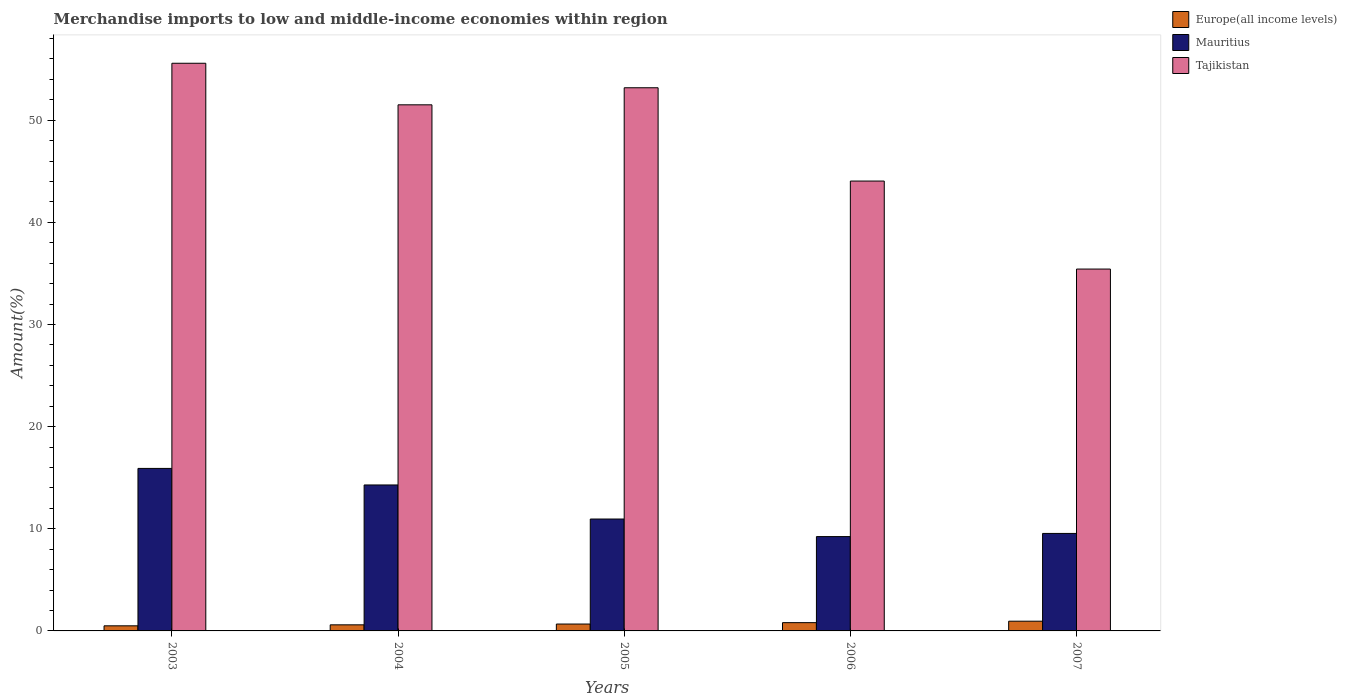How many groups of bars are there?
Offer a terse response. 5. How many bars are there on the 1st tick from the right?
Give a very brief answer. 3. What is the label of the 4th group of bars from the left?
Give a very brief answer. 2006. In how many cases, is the number of bars for a given year not equal to the number of legend labels?
Provide a succinct answer. 0. What is the percentage of amount earned from merchandise imports in Mauritius in 2005?
Offer a very short reply. 10.95. Across all years, what is the maximum percentage of amount earned from merchandise imports in Europe(all income levels)?
Make the answer very short. 0.95. Across all years, what is the minimum percentage of amount earned from merchandise imports in Mauritius?
Provide a short and direct response. 9.23. In which year was the percentage of amount earned from merchandise imports in Europe(all income levels) maximum?
Offer a very short reply. 2007. In which year was the percentage of amount earned from merchandise imports in Tajikistan minimum?
Ensure brevity in your answer.  2007. What is the total percentage of amount earned from merchandise imports in Mauritius in the graph?
Your answer should be compact. 59.93. What is the difference between the percentage of amount earned from merchandise imports in Tajikistan in 2003 and that in 2005?
Offer a terse response. 2.4. What is the difference between the percentage of amount earned from merchandise imports in Europe(all income levels) in 2007 and the percentage of amount earned from merchandise imports in Mauritius in 2004?
Your response must be concise. -13.34. What is the average percentage of amount earned from merchandise imports in Tajikistan per year?
Provide a short and direct response. 47.94. In the year 2004, what is the difference between the percentage of amount earned from merchandise imports in Europe(all income levels) and percentage of amount earned from merchandise imports in Tajikistan?
Offer a terse response. -50.91. What is the ratio of the percentage of amount earned from merchandise imports in Europe(all income levels) in 2006 to that in 2007?
Offer a terse response. 0.85. Is the percentage of amount earned from merchandise imports in Mauritius in 2005 less than that in 2007?
Ensure brevity in your answer.  No. What is the difference between the highest and the second highest percentage of amount earned from merchandise imports in Europe(all income levels)?
Your answer should be compact. 0.14. What is the difference between the highest and the lowest percentage of amount earned from merchandise imports in Tajikistan?
Your response must be concise. 20.15. In how many years, is the percentage of amount earned from merchandise imports in Europe(all income levels) greater than the average percentage of amount earned from merchandise imports in Europe(all income levels) taken over all years?
Make the answer very short. 2. What does the 3rd bar from the left in 2006 represents?
Provide a succinct answer. Tajikistan. What does the 1st bar from the right in 2003 represents?
Your answer should be compact. Tajikistan. Is it the case that in every year, the sum of the percentage of amount earned from merchandise imports in Mauritius and percentage of amount earned from merchandise imports in Europe(all income levels) is greater than the percentage of amount earned from merchandise imports in Tajikistan?
Your answer should be compact. No. How many bars are there?
Give a very brief answer. 15. Are the values on the major ticks of Y-axis written in scientific E-notation?
Make the answer very short. No. Does the graph contain grids?
Offer a terse response. No. How are the legend labels stacked?
Your answer should be very brief. Vertical. What is the title of the graph?
Give a very brief answer. Merchandise imports to low and middle-income economies within region. Does "El Salvador" appear as one of the legend labels in the graph?
Provide a short and direct response. No. What is the label or title of the Y-axis?
Ensure brevity in your answer.  Amount(%). What is the Amount(%) of Europe(all income levels) in 2003?
Keep it short and to the point. 0.5. What is the Amount(%) in Mauritius in 2003?
Offer a very short reply. 15.91. What is the Amount(%) in Tajikistan in 2003?
Offer a very short reply. 55.57. What is the Amount(%) in Europe(all income levels) in 2004?
Keep it short and to the point. 0.6. What is the Amount(%) in Mauritius in 2004?
Your answer should be very brief. 14.29. What is the Amount(%) of Tajikistan in 2004?
Make the answer very short. 51.5. What is the Amount(%) in Europe(all income levels) in 2005?
Your answer should be compact. 0.67. What is the Amount(%) in Mauritius in 2005?
Offer a very short reply. 10.95. What is the Amount(%) in Tajikistan in 2005?
Make the answer very short. 53.18. What is the Amount(%) of Europe(all income levels) in 2006?
Ensure brevity in your answer.  0.81. What is the Amount(%) in Mauritius in 2006?
Keep it short and to the point. 9.23. What is the Amount(%) in Tajikistan in 2006?
Your answer should be very brief. 44.04. What is the Amount(%) in Europe(all income levels) in 2007?
Offer a terse response. 0.95. What is the Amount(%) in Mauritius in 2007?
Ensure brevity in your answer.  9.55. What is the Amount(%) of Tajikistan in 2007?
Keep it short and to the point. 35.43. Across all years, what is the maximum Amount(%) of Europe(all income levels)?
Keep it short and to the point. 0.95. Across all years, what is the maximum Amount(%) in Mauritius?
Keep it short and to the point. 15.91. Across all years, what is the maximum Amount(%) in Tajikistan?
Provide a short and direct response. 55.57. Across all years, what is the minimum Amount(%) in Europe(all income levels)?
Offer a terse response. 0.5. Across all years, what is the minimum Amount(%) of Mauritius?
Give a very brief answer. 9.23. Across all years, what is the minimum Amount(%) of Tajikistan?
Offer a very short reply. 35.43. What is the total Amount(%) in Europe(all income levels) in the graph?
Provide a succinct answer. 3.53. What is the total Amount(%) of Mauritius in the graph?
Provide a succinct answer. 59.93. What is the total Amount(%) in Tajikistan in the graph?
Ensure brevity in your answer.  239.72. What is the difference between the Amount(%) in Europe(all income levels) in 2003 and that in 2004?
Offer a terse response. -0.1. What is the difference between the Amount(%) of Mauritius in 2003 and that in 2004?
Give a very brief answer. 1.62. What is the difference between the Amount(%) in Tajikistan in 2003 and that in 2004?
Ensure brevity in your answer.  4.07. What is the difference between the Amount(%) in Europe(all income levels) in 2003 and that in 2005?
Offer a very short reply. -0.17. What is the difference between the Amount(%) of Mauritius in 2003 and that in 2005?
Your answer should be compact. 4.96. What is the difference between the Amount(%) of Tajikistan in 2003 and that in 2005?
Give a very brief answer. 2.4. What is the difference between the Amount(%) in Europe(all income levels) in 2003 and that in 2006?
Offer a terse response. -0.31. What is the difference between the Amount(%) of Mauritius in 2003 and that in 2006?
Your answer should be compact. 6.68. What is the difference between the Amount(%) of Tajikistan in 2003 and that in 2006?
Your answer should be compact. 11.53. What is the difference between the Amount(%) in Europe(all income levels) in 2003 and that in 2007?
Provide a short and direct response. -0.45. What is the difference between the Amount(%) of Mauritius in 2003 and that in 2007?
Make the answer very short. 6.37. What is the difference between the Amount(%) of Tajikistan in 2003 and that in 2007?
Make the answer very short. 20.15. What is the difference between the Amount(%) in Europe(all income levels) in 2004 and that in 2005?
Make the answer very short. -0.08. What is the difference between the Amount(%) in Mauritius in 2004 and that in 2005?
Provide a short and direct response. 3.34. What is the difference between the Amount(%) of Tajikistan in 2004 and that in 2005?
Provide a succinct answer. -1.67. What is the difference between the Amount(%) of Europe(all income levels) in 2004 and that in 2006?
Keep it short and to the point. -0.22. What is the difference between the Amount(%) of Mauritius in 2004 and that in 2006?
Offer a very short reply. 5.05. What is the difference between the Amount(%) of Tajikistan in 2004 and that in 2006?
Your answer should be very brief. 7.46. What is the difference between the Amount(%) of Europe(all income levels) in 2004 and that in 2007?
Make the answer very short. -0.36. What is the difference between the Amount(%) in Mauritius in 2004 and that in 2007?
Provide a short and direct response. 4.74. What is the difference between the Amount(%) of Tajikistan in 2004 and that in 2007?
Keep it short and to the point. 16.08. What is the difference between the Amount(%) of Europe(all income levels) in 2005 and that in 2006?
Provide a succinct answer. -0.14. What is the difference between the Amount(%) of Mauritius in 2005 and that in 2006?
Your response must be concise. 1.72. What is the difference between the Amount(%) of Tajikistan in 2005 and that in 2006?
Your answer should be very brief. 9.13. What is the difference between the Amount(%) in Europe(all income levels) in 2005 and that in 2007?
Keep it short and to the point. -0.28. What is the difference between the Amount(%) of Mauritius in 2005 and that in 2007?
Your answer should be very brief. 1.41. What is the difference between the Amount(%) in Tajikistan in 2005 and that in 2007?
Provide a short and direct response. 17.75. What is the difference between the Amount(%) in Europe(all income levels) in 2006 and that in 2007?
Offer a terse response. -0.14. What is the difference between the Amount(%) of Mauritius in 2006 and that in 2007?
Keep it short and to the point. -0.31. What is the difference between the Amount(%) in Tajikistan in 2006 and that in 2007?
Make the answer very short. 8.61. What is the difference between the Amount(%) of Europe(all income levels) in 2003 and the Amount(%) of Mauritius in 2004?
Keep it short and to the point. -13.79. What is the difference between the Amount(%) of Europe(all income levels) in 2003 and the Amount(%) of Tajikistan in 2004?
Keep it short and to the point. -51.01. What is the difference between the Amount(%) in Mauritius in 2003 and the Amount(%) in Tajikistan in 2004?
Make the answer very short. -35.59. What is the difference between the Amount(%) in Europe(all income levels) in 2003 and the Amount(%) in Mauritius in 2005?
Your answer should be compact. -10.45. What is the difference between the Amount(%) in Europe(all income levels) in 2003 and the Amount(%) in Tajikistan in 2005?
Give a very brief answer. -52.68. What is the difference between the Amount(%) of Mauritius in 2003 and the Amount(%) of Tajikistan in 2005?
Provide a succinct answer. -37.27. What is the difference between the Amount(%) in Europe(all income levels) in 2003 and the Amount(%) in Mauritius in 2006?
Your answer should be very brief. -8.74. What is the difference between the Amount(%) of Europe(all income levels) in 2003 and the Amount(%) of Tajikistan in 2006?
Keep it short and to the point. -43.54. What is the difference between the Amount(%) of Mauritius in 2003 and the Amount(%) of Tajikistan in 2006?
Your answer should be compact. -28.13. What is the difference between the Amount(%) of Europe(all income levels) in 2003 and the Amount(%) of Mauritius in 2007?
Your answer should be compact. -9.05. What is the difference between the Amount(%) of Europe(all income levels) in 2003 and the Amount(%) of Tajikistan in 2007?
Your answer should be compact. -34.93. What is the difference between the Amount(%) in Mauritius in 2003 and the Amount(%) in Tajikistan in 2007?
Your answer should be compact. -19.52. What is the difference between the Amount(%) in Europe(all income levels) in 2004 and the Amount(%) in Mauritius in 2005?
Offer a very short reply. -10.36. What is the difference between the Amount(%) in Europe(all income levels) in 2004 and the Amount(%) in Tajikistan in 2005?
Your response must be concise. -52.58. What is the difference between the Amount(%) in Mauritius in 2004 and the Amount(%) in Tajikistan in 2005?
Your response must be concise. -38.89. What is the difference between the Amount(%) in Europe(all income levels) in 2004 and the Amount(%) in Mauritius in 2006?
Give a very brief answer. -8.64. What is the difference between the Amount(%) of Europe(all income levels) in 2004 and the Amount(%) of Tajikistan in 2006?
Your response must be concise. -43.45. What is the difference between the Amount(%) in Mauritius in 2004 and the Amount(%) in Tajikistan in 2006?
Provide a short and direct response. -29.75. What is the difference between the Amount(%) of Europe(all income levels) in 2004 and the Amount(%) of Mauritius in 2007?
Your answer should be very brief. -8.95. What is the difference between the Amount(%) of Europe(all income levels) in 2004 and the Amount(%) of Tajikistan in 2007?
Give a very brief answer. -34.83. What is the difference between the Amount(%) of Mauritius in 2004 and the Amount(%) of Tajikistan in 2007?
Offer a terse response. -21.14. What is the difference between the Amount(%) of Europe(all income levels) in 2005 and the Amount(%) of Mauritius in 2006?
Offer a very short reply. -8.56. What is the difference between the Amount(%) in Europe(all income levels) in 2005 and the Amount(%) in Tajikistan in 2006?
Make the answer very short. -43.37. What is the difference between the Amount(%) of Mauritius in 2005 and the Amount(%) of Tajikistan in 2006?
Offer a terse response. -33.09. What is the difference between the Amount(%) of Europe(all income levels) in 2005 and the Amount(%) of Mauritius in 2007?
Provide a succinct answer. -8.87. What is the difference between the Amount(%) in Europe(all income levels) in 2005 and the Amount(%) in Tajikistan in 2007?
Keep it short and to the point. -34.75. What is the difference between the Amount(%) of Mauritius in 2005 and the Amount(%) of Tajikistan in 2007?
Give a very brief answer. -24.47. What is the difference between the Amount(%) in Europe(all income levels) in 2006 and the Amount(%) in Mauritius in 2007?
Your answer should be compact. -8.73. What is the difference between the Amount(%) in Europe(all income levels) in 2006 and the Amount(%) in Tajikistan in 2007?
Keep it short and to the point. -34.62. What is the difference between the Amount(%) in Mauritius in 2006 and the Amount(%) in Tajikistan in 2007?
Your answer should be very brief. -26.19. What is the average Amount(%) of Europe(all income levels) per year?
Offer a terse response. 0.71. What is the average Amount(%) of Mauritius per year?
Give a very brief answer. 11.99. What is the average Amount(%) of Tajikistan per year?
Keep it short and to the point. 47.95. In the year 2003, what is the difference between the Amount(%) in Europe(all income levels) and Amount(%) in Mauritius?
Make the answer very short. -15.41. In the year 2003, what is the difference between the Amount(%) of Europe(all income levels) and Amount(%) of Tajikistan?
Offer a very short reply. -55.07. In the year 2003, what is the difference between the Amount(%) in Mauritius and Amount(%) in Tajikistan?
Your answer should be very brief. -39.66. In the year 2004, what is the difference between the Amount(%) of Europe(all income levels) and Amount(%) of Mauritius?
Provide a short and direct response. -13.69. In the year 2004, what is the difference between the Amount(%) in Europe(all income levels) and Amount(%) in Tajikistan?
Provide a succinct answer. -50.91. In the year 2004, what is the difference between the Amount(%) of Mauritius and Amount(%) of Tajikistan?
Offer a terse response. -37.22. In the year 2005, what is the difference between the Amount(%) in Europe(all income levels) and Amount(%) in Mauritius?
Your answer should be compact. -10.28. In the year 2005, what is the difference between the Amount(%) in Europe(all income levels) and Amount(%) in Tajikistan?
Your answer should be compact. -52.5. In the year 2005, what is the difference between the Amount(%) of Mauritius and Amount(%) of Tajikistan?
Your response must be concise. -42.22. In the year 2006, what is the difference between the Amount(%) in Europe(all income levels) and Amount(%) in Mauritius?
Keep it short and to the point. -8.42. In the year 2006, what is the difference between the Amount(%) of Europe(all income levels) and Amount(%) of Tajikistan?
Give a very brief answer. -43.23. In the year 2006, what is the difference between the Amount(%) in Mauritius and Amount(%) in Tajikistan?
Provide a succinct answer. -34.81. In the year 2007, what is the difference between the Amount(%) in Europe(all income levels) and Amount(%) in Mauritius?
Your answer should be compact. -8.59. In the year 2007, what is the difference between the Amount(%) in Europe(all income levels) and Amount(%) in Tajikistan?
Give a very brief answer. -34.48. In the year 2007, what is the difference between the Amount(%) in Mauritius and Amount(%) in Tajikistan?
Your answer should be very brief. -25.88. What is the ratio of the Amount(%) of Europe(all income levels) in 2003 to that in 2004?
Your answer should be compact. 0.84. What is the ratio of the Amount(%) of Mauritius in 2003 to that in 2004?
Keep it short and to the point. 1.11. What is the ratio of the Amount(%) in Tajikistan in 2003 to that in 2004?
Your response must be concise. 1.08. What is the ratio of the Amount(%) in Europe(all income levels) in 2003 to that in 2005?
Provide a short and direct response. 0.74. What is the ratio of the Amount(%) in Mauritius in 2003 to that in 2005?
Ensure brevity in your answer.  1.45. What is the ratio of the Amount(%) of Tajikistan in 2003 to that in 2005?
Make the answer very short. 1.05. What is the ratio of the Amount(%) of Europe(all income levels) in 2003 to that in 2006?
Keep it short and to the point. 0.62. What is the ratio of the Amount(%) in Mauritius in 2003 to that in 2006?
Offer a terse response. 1.72. What is the ratio of the Amount(%) of Tajikistan in 2003 to that in 2006?
Provide a short and direct response. 1.26. What is the ratio of the Amount(%) of Europe(all income levels) in 2003 to that in 2007?
Your answer should be compact. 0.52. What is the ratio of the Amount(%) in Mauritius in 2003 to that in 2007?
Your answer should be compact. 1.67. What is the ratio of the Amount(%) in Tajikistan in 2003 to that in 2007?
Your answer should be very brief. 1.57. What is the ratio of the Amount(%) in Europe(all income levels) in 2004 to that in 2005?
Provide a short and direct response. 0.88. What is the ratio of the Amount(%) of Mauritius in 2004 to that in 2005?
Provide a short and direct response. 1.3. What is the ratio of the Amount(%) of Tajikistan in 2004 to that in 2005?
Your answer should be very brief. 0.97. What is the ratio of the Amount(%) of Europe(all income levels) in 2004 to that in 2006?
Offer a very short reply. 0.73. What is the ratio of the Amount(%) of Mauritius in 2004 to that in 2006?
Provide a short and direct response. 1.55. What is the ratio of the Amount(%) of Tajikistan in 2004 to that in 2006?
Keep it short and to the point. 1.17. What is the ratio of the Amount(%) of Europe(all income levels) in 2004 to that in 2007?
Keep it short and to the point. 0.63. What is the ratio of the Amount(%) of Mauritius in 2004 to that in 2007?
Provide a succinct answer. 1.5. What is the ratio of the Amount(%) of Tajikistan in 2004 to that in 2007?
Provide a succinct answer. 1.45. What is the ratio of the Amount(%) of Europe(all income levels) in 2005 to that in 2006?
Ensure brevity in your answer.  0.83. What is the ratio of the Amount(%) of Mauritius in 2005 to that in 2006?
Make the answer very short. 1.19. What is the ratio of the Amount(%) of Tajikistan in 2005 to that in 2006?
Offer a terse response. 1.21. What is the ratio of the Amount(%) of Europe(all income levels) in 2005 to that in 2007?
Your response must be concise. 0.71. What is the ratio of the Amount(%) in Mauritius in 2005 to that in 2007?
Make the answer very short. 1.15. What is the ratio of the Amount(%) of Tajikistan in 2005 to that in 2007?
Offer a very short reply. 1.5. What is the ratio of the Amount(%) in Europe(all income levels) in 2006 to that in 2007?
Keep it short and to the point. 0.85. What is the ratio of the Amount(%) in Mauritius in 2006 to that in 2007?
Provide a succinct answer. 0.97. What is the ratio of the Amount(%) in Tajikistan in 2006 to that in 2007?
Your answer should be very brief. 1.24. What is the difference between the highest and the second highest Amount(%) in Europe(all income levels)?
Offer a very short reply. 0.14. What is the difference between the highest and the second highest Amount(%) of Mauritius?
Your answer should be very brief. 1.62. What is the difference between the highest and the second highest Amount(%) in Tajikistan?
Provide a succinct answer. 2.4. What is the difference between the highest and the lowest Amount(%) of Europe(all income levels)?
Your answer should be compact. 0.45. What is the difference between the highest and the lowest Amount(%) of Mauritius?
Keep it short and to the point. 6.68. What is the difference between the highest and the lowest Amount(%) of Tajikistan?
Ensure brevity in your answer.  20.15. 